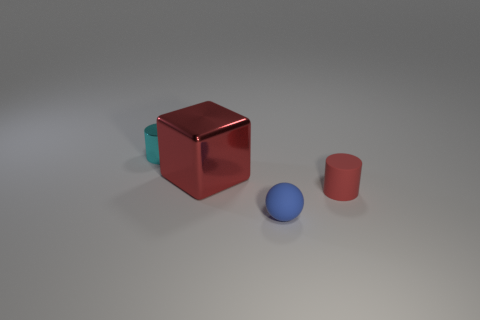There is a cyan shiny object that is the same size as the rubber cylinder; what shape is it?
Provide a short and direct response. Cylinder. What number of things are either rubber cylinders or small rubber things?
Your answer should be compact. 2. Are any brown objects visible?
Keep it short and to the point. No. Is the number of balls less than the number of rubber things?
Your answer should be very brief. Yes. Is there a red cylinder that has the same size as the cyan thing?
Offer a very short reply. Yes. There is a small red thing; is its shape the same as the shiny thing left of the big red shiny object?
Offer a terse response. Yes. What number of blocks are tiny yellow rubber things or blue objects?
Keep it short and to the point. 0. What is the color of the tiny shiny object?
Offer a terse response. Cyan. Are there more small purple shiny cubes than large red metal things?
Give a very brief answer. No. How many objects are either matte things on the right side of the ball or red matte cylinders?
Give a very brief answer. 1. 